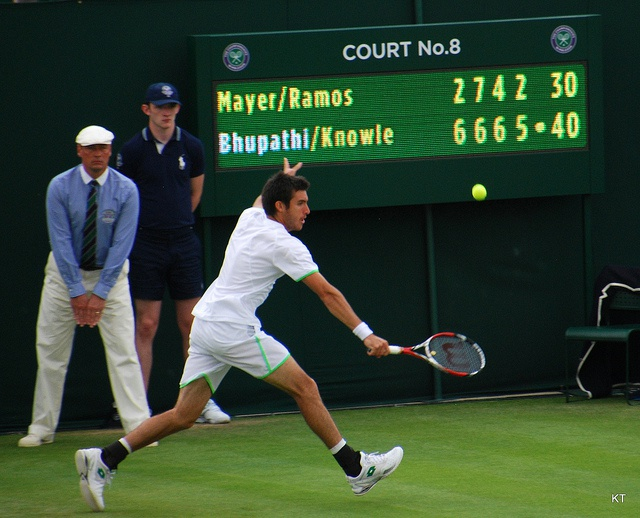Describe the objects in this image and their specific colors. I can see people in black, lavender, darkgray, and olive tones, people in black, darkgray, and gray tones, people in black, maroon, and brown tones, chair in black, teal, darkgreen, and darkgray tones, and tennis racket in black, purple, and lightgray tones in this image. 